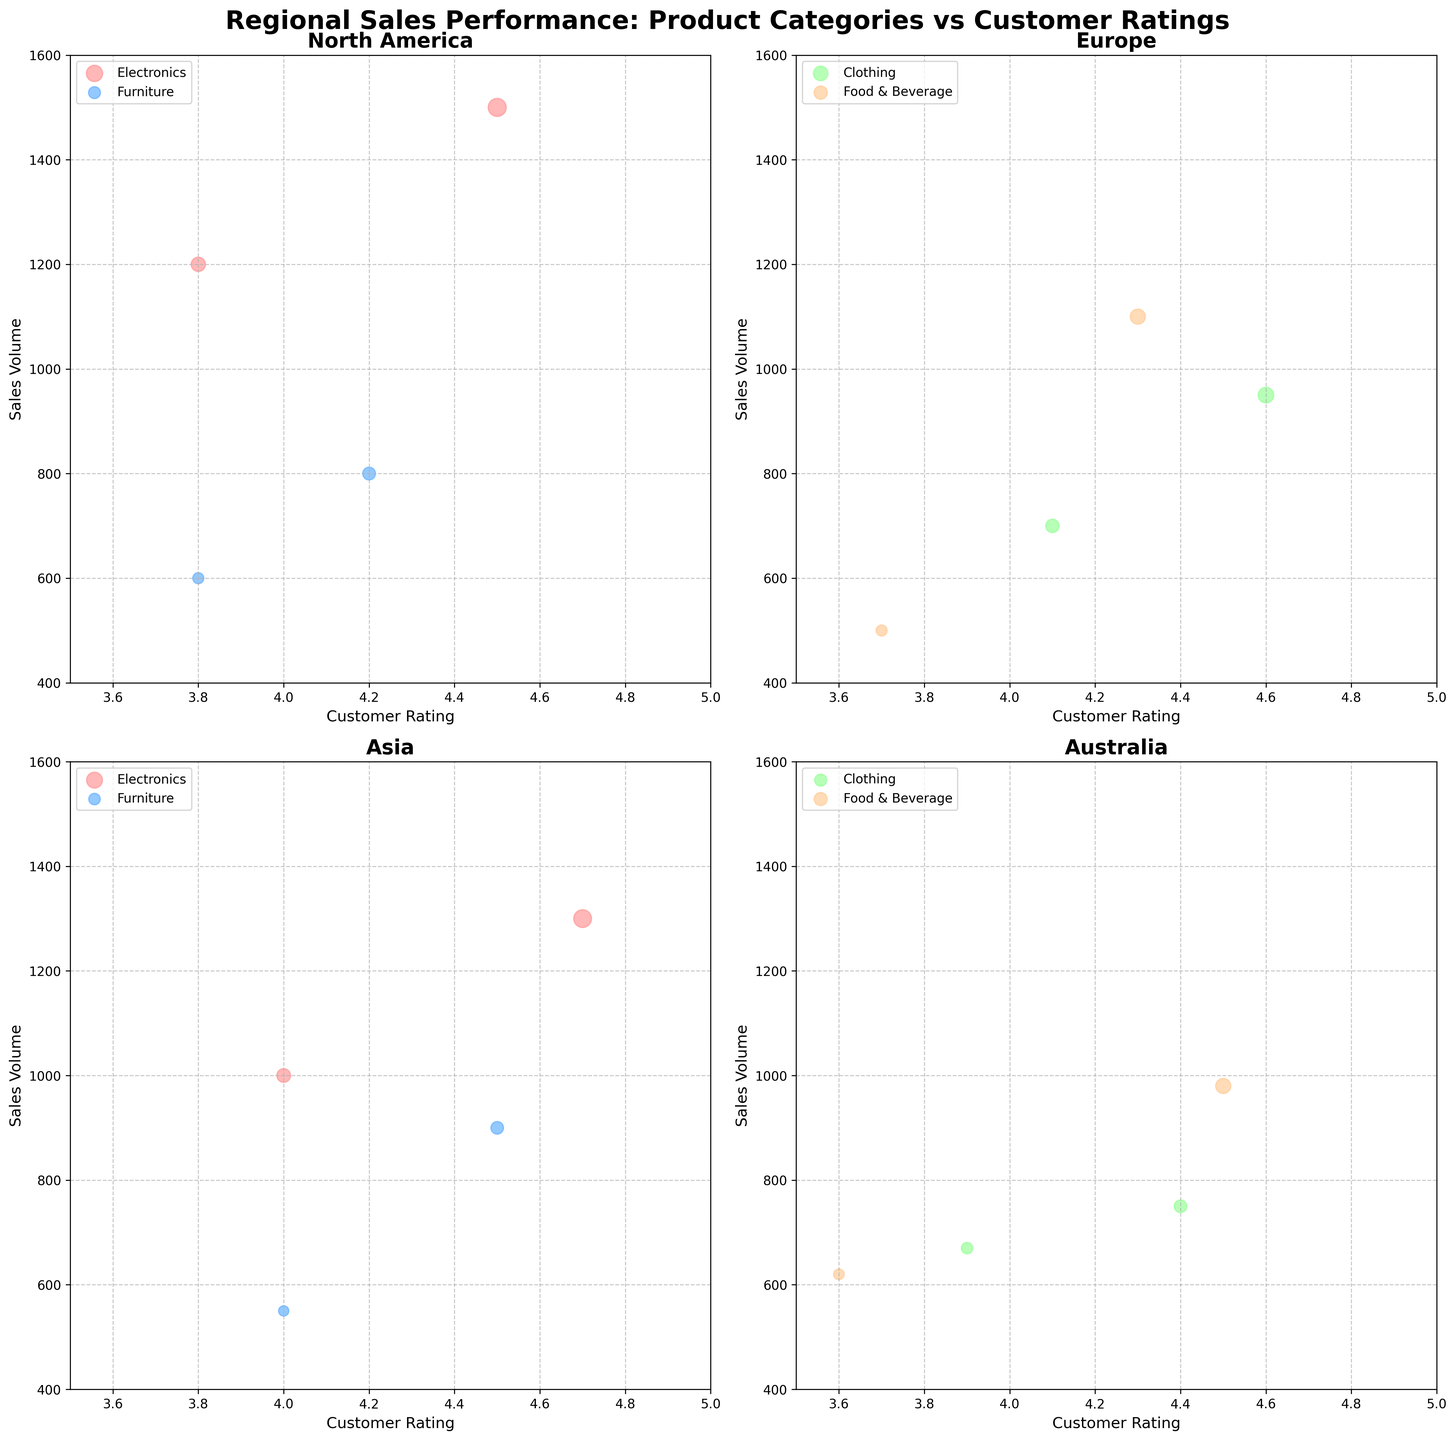What is the title of the figure? The title of the figure is prominently displayed at the top and reads "Regional Sales Performance: Product Categories vs Customer Ratings."
Answer: Regional Sales Performance: Product Categories vs Customer Ratings How many regions are compared in this figure? There are four subplots, each representing a different region as indicated by the titles of each subplot.
Answer: 4 What is the range of Customer Ratings displayed on the x-axis? The x-axis across all subplots is labeled as Customer Ratings, with the range consistently set from 3.5 to 5.0.
Answer: 3.5 to 5.0 Which product category in Asia has the highest customer rating? By examining the Asia subplot, the Electronics category has bubbles at a Customer Rating of 4.7, which is the highest among categories shown.
Answer: Electronics Which region shows the highest sales volume for Furniture? Looking at the subplots for each region, the North America subplot shows a Sales Volume of 800 units for Furniture, which is the highest when compared to other regions.
Answer: North America In Europe, what is the product category with the smallest bubble size, and what does it represent? In the Europe subplot, the Food & Beverage category has the smallest bubbles, which represent lower profit values as indicated by the scatter plot configuration.
Answer: Food & Beverage, lower profit Between North America and Asia, which region has a higher average sales volume for Electronics? In North America, the sales volumes for Electronics are 1500 and 1200. In Asia, the sales volumes for Electronics are 1300 and 1000. Average for NA = (1500 + 1200) / 2 = 1350, and for Asia = (1300 + 1000) / 2 = 1150. Thus, North America has a higher average.
Answer: North America Regarding the Clothing category, compare the average customer rating in Europe and Australia. Europe has ratings of 4.6 and 4.1, averaging (4.6 + 4.1) / 2 = 4.35. Australia has ratings of 4.4 and 3.9, averaging (4.4 + 3.9) / 2 = 4.15. Europe has a higher average customer rating.
Answer: Europe Which region has the broadest range of sales volume values? By examining the y-axes of each subplot, North America ranges from 600 to 1500, Europe from 500 to 1100, Asia from 550 to 1300, and Australia from 620 to 980. North America has the broadest range of 900 units.
Answer: North America 